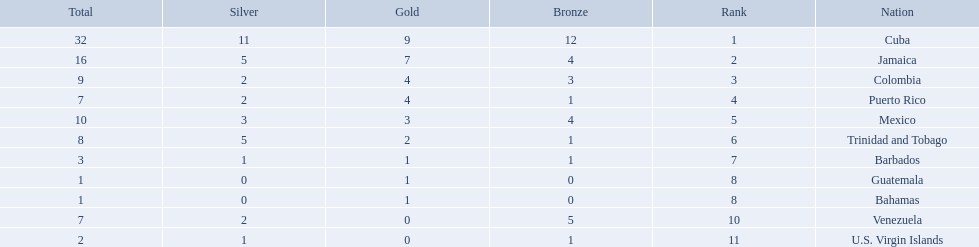Which teams have at exactly 4 gold medals? Colombia, Puerto Rico. Of those teams which has exactly 1 bronze medal? Puerto Rico. 